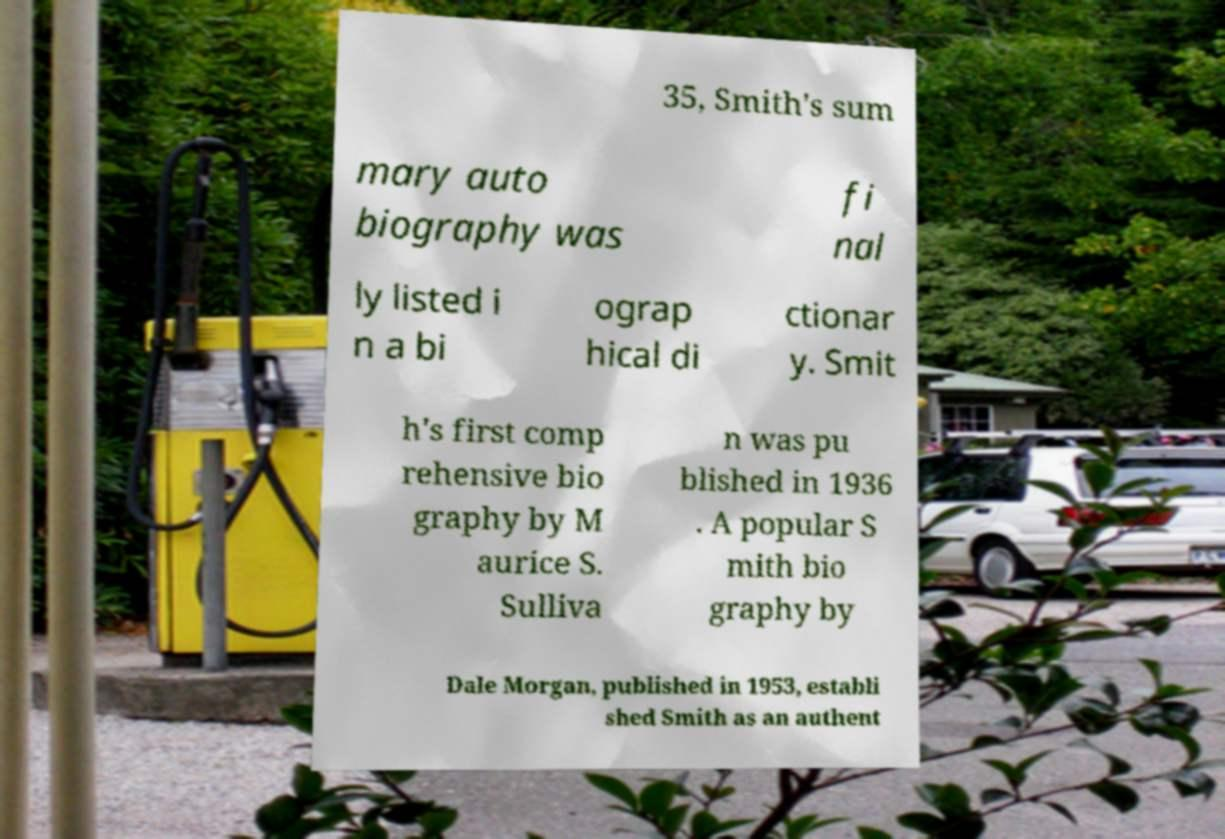Can you accurately transcribe the text from the provided image for me? 35, Smith's sum mary auto biography was fi nal ly listed i n a bi ograp hical di ctionar y. Smit h's first comp rehensive bio graphy by M aurice S. Sulliva n was pu blished in 1936 . A popular S mith bio graphy by Dale Morgan, published in 1953, establi shed Smith as an authent 